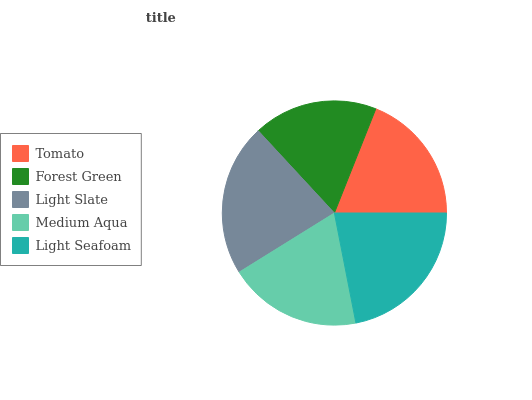Is Forest Green the minimum?
Answer yes or no. Yes. Is Light Slate the maximum?
Answer yes or no. Yes. Is Light Slate the minimum?
Answer yes or no. No. Is Forest Green the maximum?
Answer yes or no. No. Is Light Slate greater than Forest Green?
Answer yes or no. Yes. Is Forest Green less than Light Slate?
Answer yes or no. Yes. Is Forest Green greater than Light Slate?
Answer yes or no. No. Is Light Slate less than Forest Green?
Answer yes or no. No. Is Medium Aqua the high median?
Answer yes or no. Yes. Is Medium Aqua the low median?
Answer yes or no. Yes. Is Light Seafoam the high median?
Answer yes or no. No. Is Forest Green the low median?
Answer yes or no. No. 